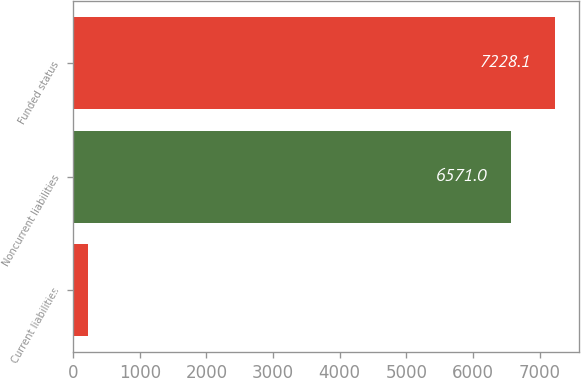<chart> <loc_0><loc_0><loc_500><loc_500><bar_chart><fcel>Current liabilities<fcel>Noncurrent liabilities<fcel>Funded status<nl><fcel>232<fcel>6571<fcel>7228.1<nl></chart> 